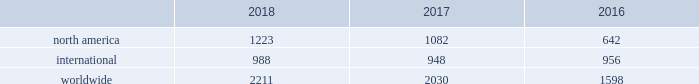32 | bhge 2018 form 10-k baker hughes rig count the baker hughes rig counts are an important business barometer for the drilling industry and its suppliers .
When drilling rigs are active they consume products and services produced by the oil service industry .
Rig count trends are driven by the exploration and development spending by oil and natural gas companies , which in turn is influenced by current and future price expectations for oil and natural gas .
The counts may reflect the relative strength and stability of energy prices and overall market activity , however , these counts should not be solely relied on as other specific and pervasive conditions may exist that affect overall energy prices and market activity .
We have been providing rig counts to the public since 1944 .
We gather all relevant data through our field service personnel , who obtain the necessary data from routine visits to the various rigs , customers , contractors and other outside sources as necessary .
We base the classification of a well as either oil or natural gas primarily upon filings made by operators in the relevant jurisdiction .
This data is then compiled and distributed to various wire services and trade associations and is published on our website .
We believe the counting process and resulting data is reliable , however , it is subject to our ability to obtain accurate and timely information .
Rig counts are compiled weekly for the u.s .
And canada and monthly for all international rigs .
Published international rig counts do not include rigs drilling in certain locations , such as russia , the caspian region and onshore china because this information is not readily available .
Rigs in the u.s .
And canada are counted as active if , on the day the count is taken , the well being drilled has been started but drilling has not been completed and the well is anticipated to be of sufficient depth to be a potential consumer of our drill bits .
In international areas , rigs are counted on a weekly basis and deemed active if drilling activities occurred during the majority of the week .
The weekly results are then averaged for the month and published accordingly .
The rig count does not include rigs that are in transit from one location to another , rigging up , being used in non-drilling activities including production testing , completion and workover , and are not expected to be significant consumers of drill bits .
The rig counts are summarized in the table below as averages for each of the periods indicated. .
2018 compared to 2017 overall the rig count was 2211 in 2018 , an increase of 9% ( 9 % ) as compared to 2017 due primarily to north american activity .
The rig count in north america increased 13% ( 13 % ) in 2018 compared to 2017 .
Internationally , the rig count increased 4% ( 4 % ) in 2018 as compared to the same period last year .
Within north america , the increase was primarily driven by the u.s .
Rig count , which was up 18% ( 18 % ) on average versus 2017 , partially offset with a decrease in the canadian rig count , which was down 8% ( 8 % ) on average .
Internationally , the improvement in the rig count was driven primarily by increases in the africa region of 18% ( 18 % ) , the asia-pacific region and latin america region , were also up by 9% ( 9 % ) and 3% ( 3 % ) , respectively , partially offset by the europe region , which was down 8% ( 8 % ) .
2017 compared to 2016 overall the rig count was 2030 in 2017 , an increase of 27% ( 27 % ) as compared to 2016 due primarily to north american activity .
The rig count in north america increased 69% ( 69 % ) in 2017 compared to 2016 .
Internationally , the rig count decreased 1% ( 1 % ) in 2017 as compared to the same period last year .
Within north america , the increase was primarily driven by the land rig count , which was up 72% ( 72 % ) , partially offset by a decrease in the offshore rig count of 16% ( 16 % ) .
Internationally , the rig count decrease was driven primarily by decreases in latin america of 7% ( 7 % ) , the europe region and africa region , which were down by 4% ( 4 % ) and 2% ( 2 % ) , respectively , partially offset by the asia-pacific region , which was up 8%. .
What portion of total rig count is in north america in 2018? 
Computations: (1223 - 2211)
Answer: -988.0. 